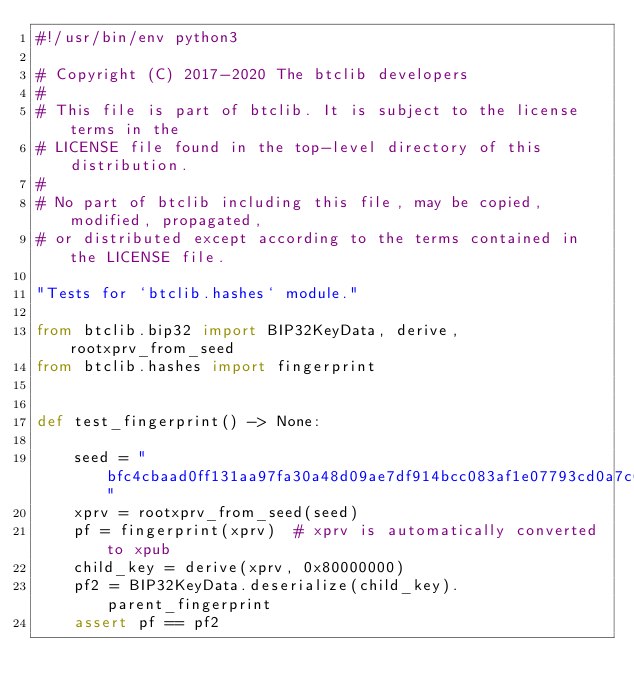Convert code to text. <code><loc_0><loc_0><loc_500><loc_500><_Python_>#!/usr/bin/env python3

# Copyright (C) 2017-2020 The btclib developers
#
# This file is part of btclib. It is subject to the license terms in the
# LICENSE file found in the top-level directory of this distribution.
#
# No part of btclib including this file, may be copied, modified, propagated,
# or distributed except according to the terms contained in the LICENSE file.

"Tests for `btclib.hashes` module."

from btclib.bip32 import BIP32KeyData, derive, rootxprv_from_seed
from btclib.hashes import fingerprint


def test_fingerprint() -> None:

    seed = "bfc4cbaad0ff131aa97fa30a48d09ae7df914bcc083af1e07793cd0a7c61a03f65d622848209ad3366a419f4718a80ec9037df107d8d12c19b83202de00a40ad"
    xprv = rootxprv_from_seed(seed)
    pf = fingerprint(xprv)  # xprv is automatically converted to xpub
    child_key = derive(xprv, 0x80000000)
    pf2 = BIP32KeyData.deserialize(child_key).parent_fingerprint
    assert pf == pf2
</code> 